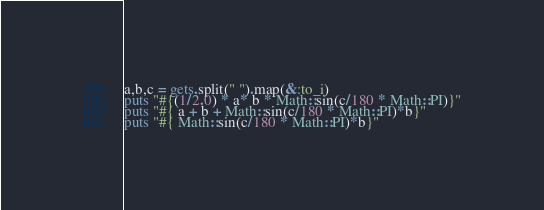Convert code to text. <code><loc_0><loc_0><loc_500><loc_500><_Ruby_>a,b,c = gets.split(" ").map(&:to_i)
puts "#{(1/2.0) * a* b * Math::sin(c/180 * Math::PI)}"
puts "#{ a + b + Math::sin(c/180 * Math::PI)*b}"
puts "#{ Math::sin(c/180 * Math::PI)*b}"</code> 